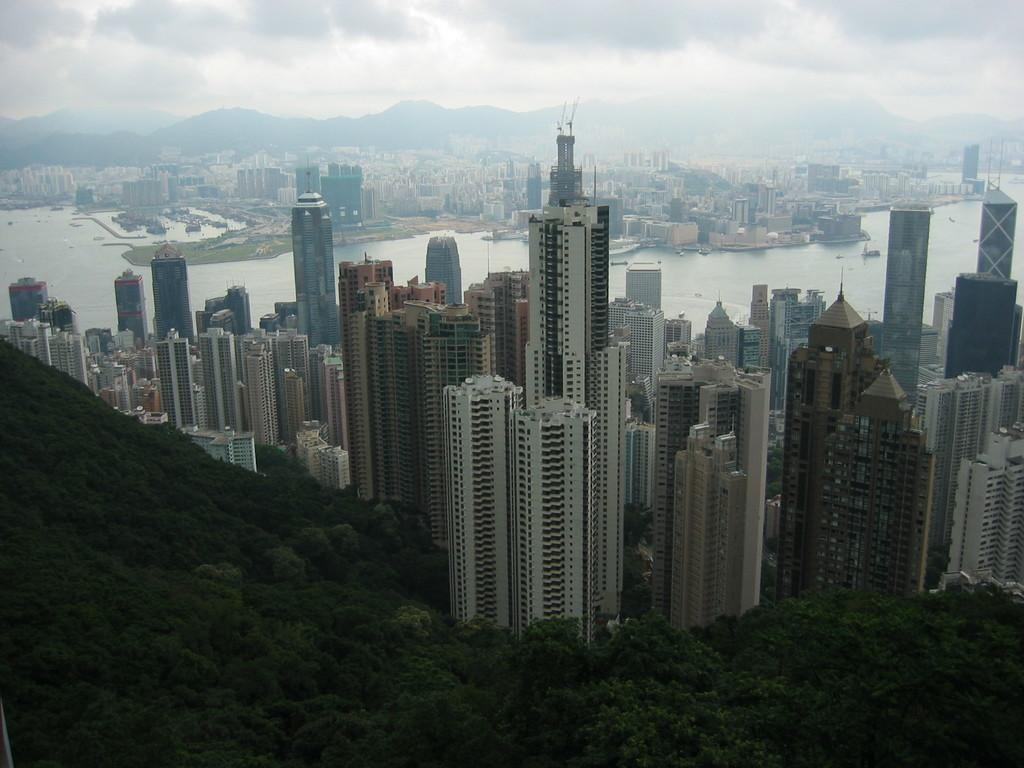What is located in the center of the image? There are buildings, trees, water, plants, and boats in the center of the image. What type of vegetation can be seen in the center of the image? There are trees and plants in the center of the image. What is the purpose of the wall in the center of the image? The purpose of the wall in the center of the image is not clear from the facts provided. What can be seen in the background of the image? The sky, clouds, and a hill can be seen in the background of the image. Where is the downtown area in the image? There is no downtown area mentioned or visible in the image. What type of bulb is used to light up the boats in the image? There is no information about lighting or bulbs in the image. What type of field can be seen in the background of the image? There is no field visible in the image; only a hill can be seen in the background. 